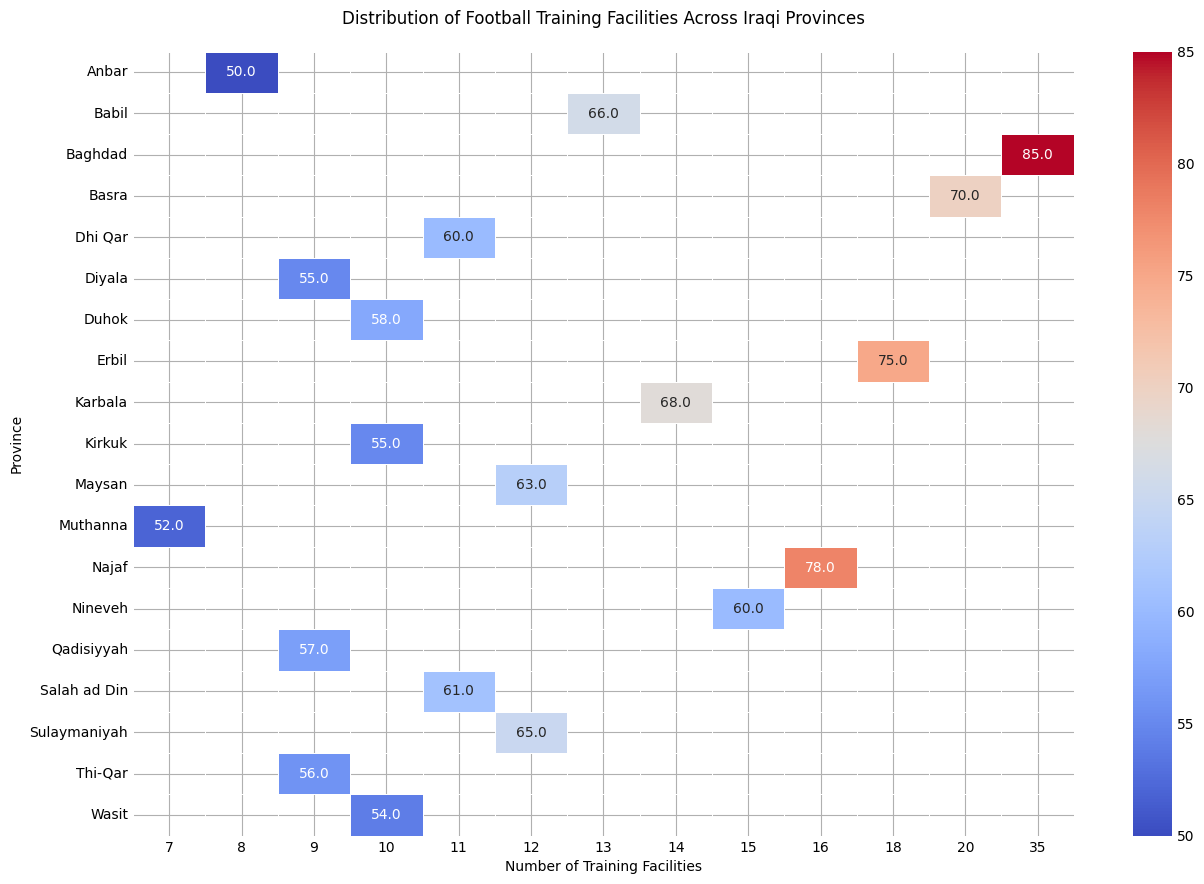What's the province with the highest number of training facilities? The heatmap shows that Baghdad has the highest number of training facilities.
Answer: Baghdad Which province has the lowest accessibility score? Identify the darkest color on the heatmap, which is found in Anbar.
Answer: Anbar By how much does the accessibility score in Baghdad exceed that of Muthanna? Look at Baghdad's score (85) and compare it to Muthanna's score (52). Subtract 52 from 85.
Answer: 33 Compare the number of training facilities between Najaf and Karbala, and which province has a higher score? Najaf has 16 training facilities, while Karbala has 14. Najaf thus has more training facilities than Karbala.
Answer: Najaf Which province with exactly 10 training facilities has the highest accessibility score? Check the scores for provinces with 10 training facilities: Kirkuk (55), Wasit (54), and Duhok (58). Duhok has the highest score among them.
Answer: Duhok What is the average accessibility score for provinces with more than 15 training facilities? Provinces with more than 15 facilities: Baghdad (85), Basra (70), Najaf (78). Sum their scores (85 + 70 + 78 = 233) and divide by the number of provinces (3).
Answer: 77.67 Which province has exact parity in scores with another province but differing in training facilities? Look for identical scores: Nineveh and Dhi Qar both have a score of 60 but different facilities (15 and 11, respectively).
Answer: Nineveh and Dhi Qar What are the two provinces closest in accessibility but differing in training facilities, and how different are their accessibilities? Closest in accessibility are Diyala (55) and Wasit (54), differing by 1 point.
Answer: Diyala and Wasit, 1 point How does Erbil's accessibility score compare to Dhi Qar's while considering their training facilities? Erbil has an accessibility score of 75 and training facilities of 18. Dhi Qar has a score of 60 and facilities of 11. Erbil has a higher score and more facilities.
Answer: Erbil, higher score and more facilities Which two provinces have facilities in single digits and similar accessibility, within 3 points difference? Look for provinces with single-digit training facilities: Anbar (50), Diyala (55), and Muthanna (52). Anbar and Muthanna differ by 2 points.
Answer: Anbar and Muthanna 